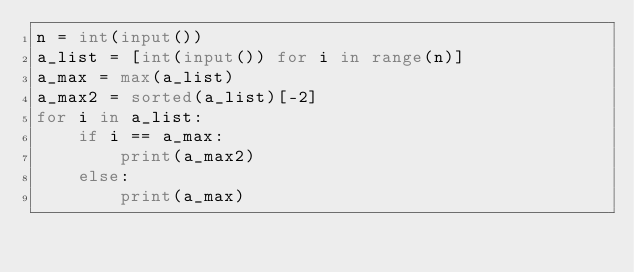Convert code to text. <code><loc_0><loc_0><loc_500><loc_500><_Python_>n = int(input())
a_list = [int(input()) for i in range(n)]
a_max = max(a_list)
a_max2 = sorted(a_list)[-2]
for i in a_list:
    if i == a_max:
        print(a_max2)
    else:
        print(a_max)</code> 